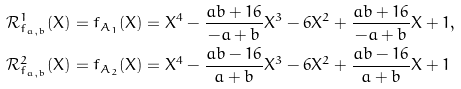<formula> <loc_0><loc_0><loc_500><loc_500>\mathcal { R } _ { f _ { a , b } } ^ { 1 } ( X ) & = f _ { A _ { 1 } } ( X ) = X ^ { 4 } - \frac { a b + 1 6 } { - a + b } X ^ { 3 } - 6 X ^ { 2 } + \frac { a b + 1 6 } { - a + b } X + 1 , \\ \mathcal { R } _ { f _ { a , b } } ^ { 2 } ( X ) & = f _ { A _ { 2 } } ( X ) = X ^ { 4 } - \frac { a b - 1 6 } { a + b } X ^ { 3 } - 6 X ^ { 2 } + \frac { a b - 1 6 } { a + b } X + 1</formula> 